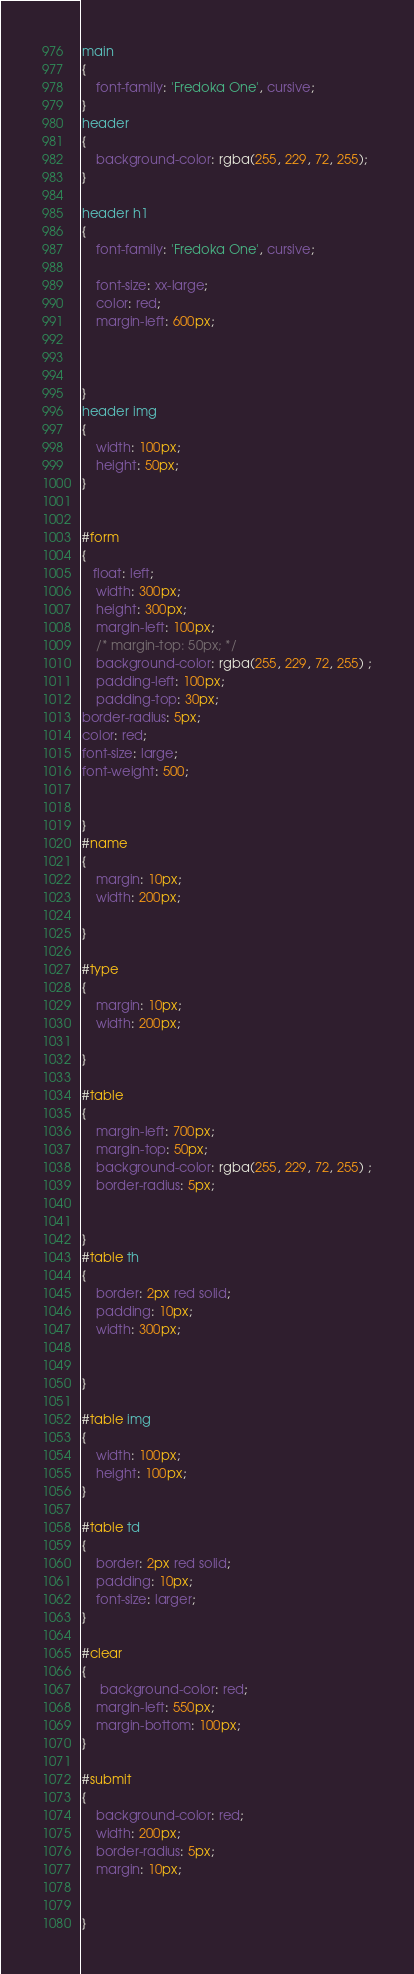<code> <loc_0><loc_0><loc_500><loc_500><_CSS_>main
{
    font-family: 'Fredoka One', cursive;
}
header
{
    background-color: rgba(255, 229, 72, 255);
}

header h1 
{
    font-family: 'Fredoka One', cursive;

    font-size: xx-large;
    color: red;
    margin-left: 600px;



}
header img
{
    width: 100px;
    height: 50px;
}


#form
{
   float: left;
    width: 300px;
    height: 300px;
    margin-left: 100px;
    /* margin-top: 50px; */
    background-color: rgba(255, 229, 72, 255) ;
    padding-left: 100px;
    padding-top: 30px;
border-radius: 5px;
color: red;
font-size: large;
font-weight: 500;


}
#name
{
    margin: 10px;
    width: 200px;

}

#type
{
    margin: 10px;
    width: 200px;

}

#table
{
    margin-left: 700px;
    margin-top: 50px;
    background-color: rgba(255, 229, 72, 255) ;
    border-radius: 5px;


}
#table th
{
    border: 2px red solid;
    padding: 10px;
    width: 300px;


}

#table img
{
    width: 100px;
    height: 100px;
}

#table td
{
    border: 2px red solid;
    padding: 10px;
    font-size: larger;
}

#clear
{
     background-color: red;
    margin-left: 550px;
    margin-bottom: 100px;
}

#submit
{
    background-color: red;
    width: 200px;
    border-radius: 5px;
    margin: 10px;


}</code> 